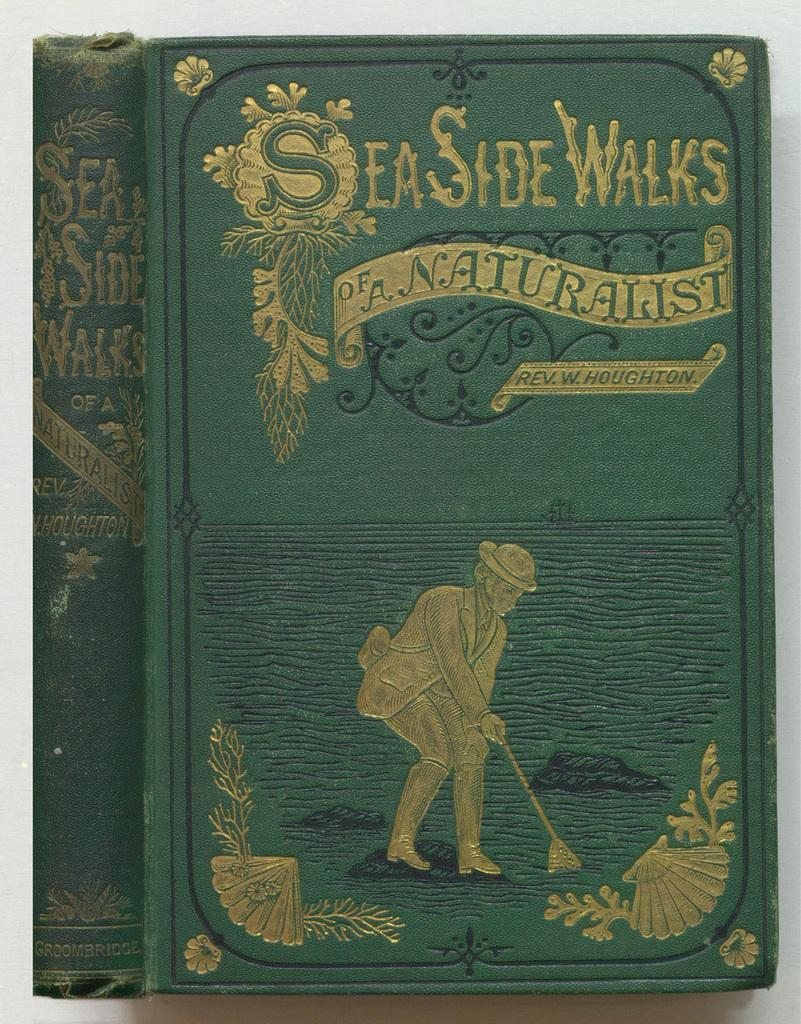<image>
Relay a brief, clear account of the picture shown. A front and side view of an old book called Seaside Walks of A Naturist. 